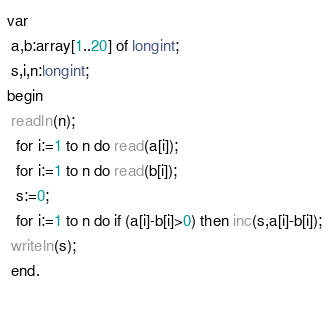Convert code to text. <code><loc_0><loc_0><loc_500><loc_500><_Pascal_>var
 a,b:array[1..20] of longint;
 s,i,n:longint;
begin
 readln(n);
  for i:=1 to n do read(a[i]);
  for i:=1 to n do read(b[i]);
  s:=0;
  for i:=1 to n do if (a[i]-b[i]>0) then inc(s,a[i]-b[i]);
 writeln(s);
 end.
  </code> 